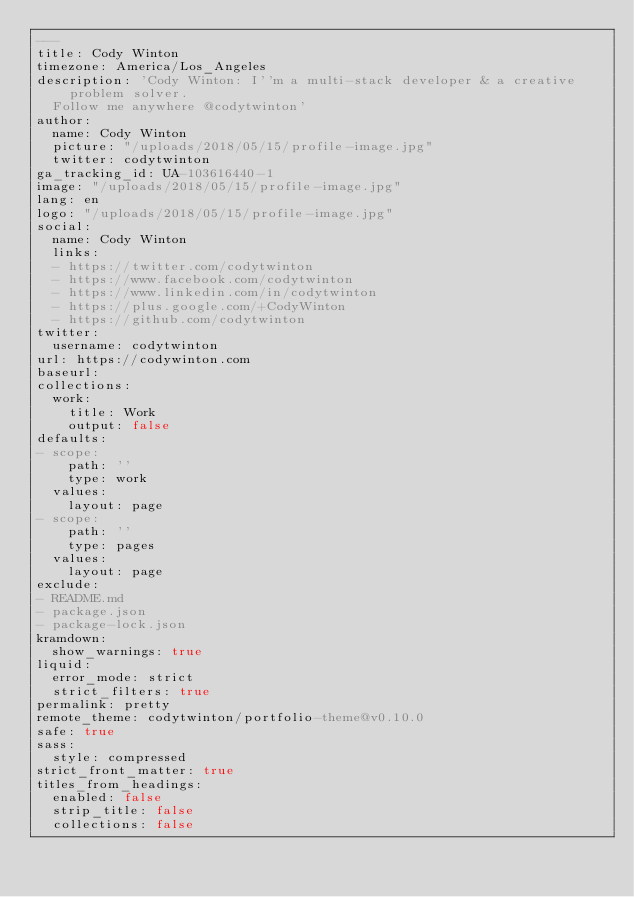<code> <loc_0><loc_0><loc_500><loc_500><_YAML_>---
title: Cody Winton
timezone: America/Los_Angeles
description: 'Cody Winton: I''m a multi-stack developer & a creative problem solver.
  Follow me anywhere @codytwinton'
author:
  name: Cody Winton
  picture: "/uploads/2018/05/15/profile-image.jpg"
  twitter: codytwinton
ga_tracking_id: UA-103616440-1
image: "/uploads/2018/05/15/profile-image.jpg"
lang: en
logo: "/uploads/2018/05/15/profile-image.jpg"
social:
  name: Cody Winton
  links:
  - https://twitter.com/codytwinton
  - https://www.facebook.com/codytwinton
  - https://www.linkedin.com/in/codytwinton
  - https://plus.google.com/+CodyWinton
  - https://github.com/codytwinton
twitter:
  username: codytwinton
url: https://codywinton.com
baseurl: 
collections:
  work:
    title: Work
    output: false
defaults:
- scope:
    path: ''
    type: work
  values:
    layout: page
- scope:
    path: ''
    type: pages
  values:
    layout: page
exclude:
- README.md
- package.json
- package-lock.json
kramdown:
  show_warnings: true
liquid:
  error_mode: strict
  strict_filters: true
permalink: pretty
remote_theme: codytwinton/portfolio-theme@v0.10.0
safe: true
sass:
  style: compressed
strict_front_matter: true
titles_from_headings:
  enabled: false
  strip_title: false
  collections: false
</code> 